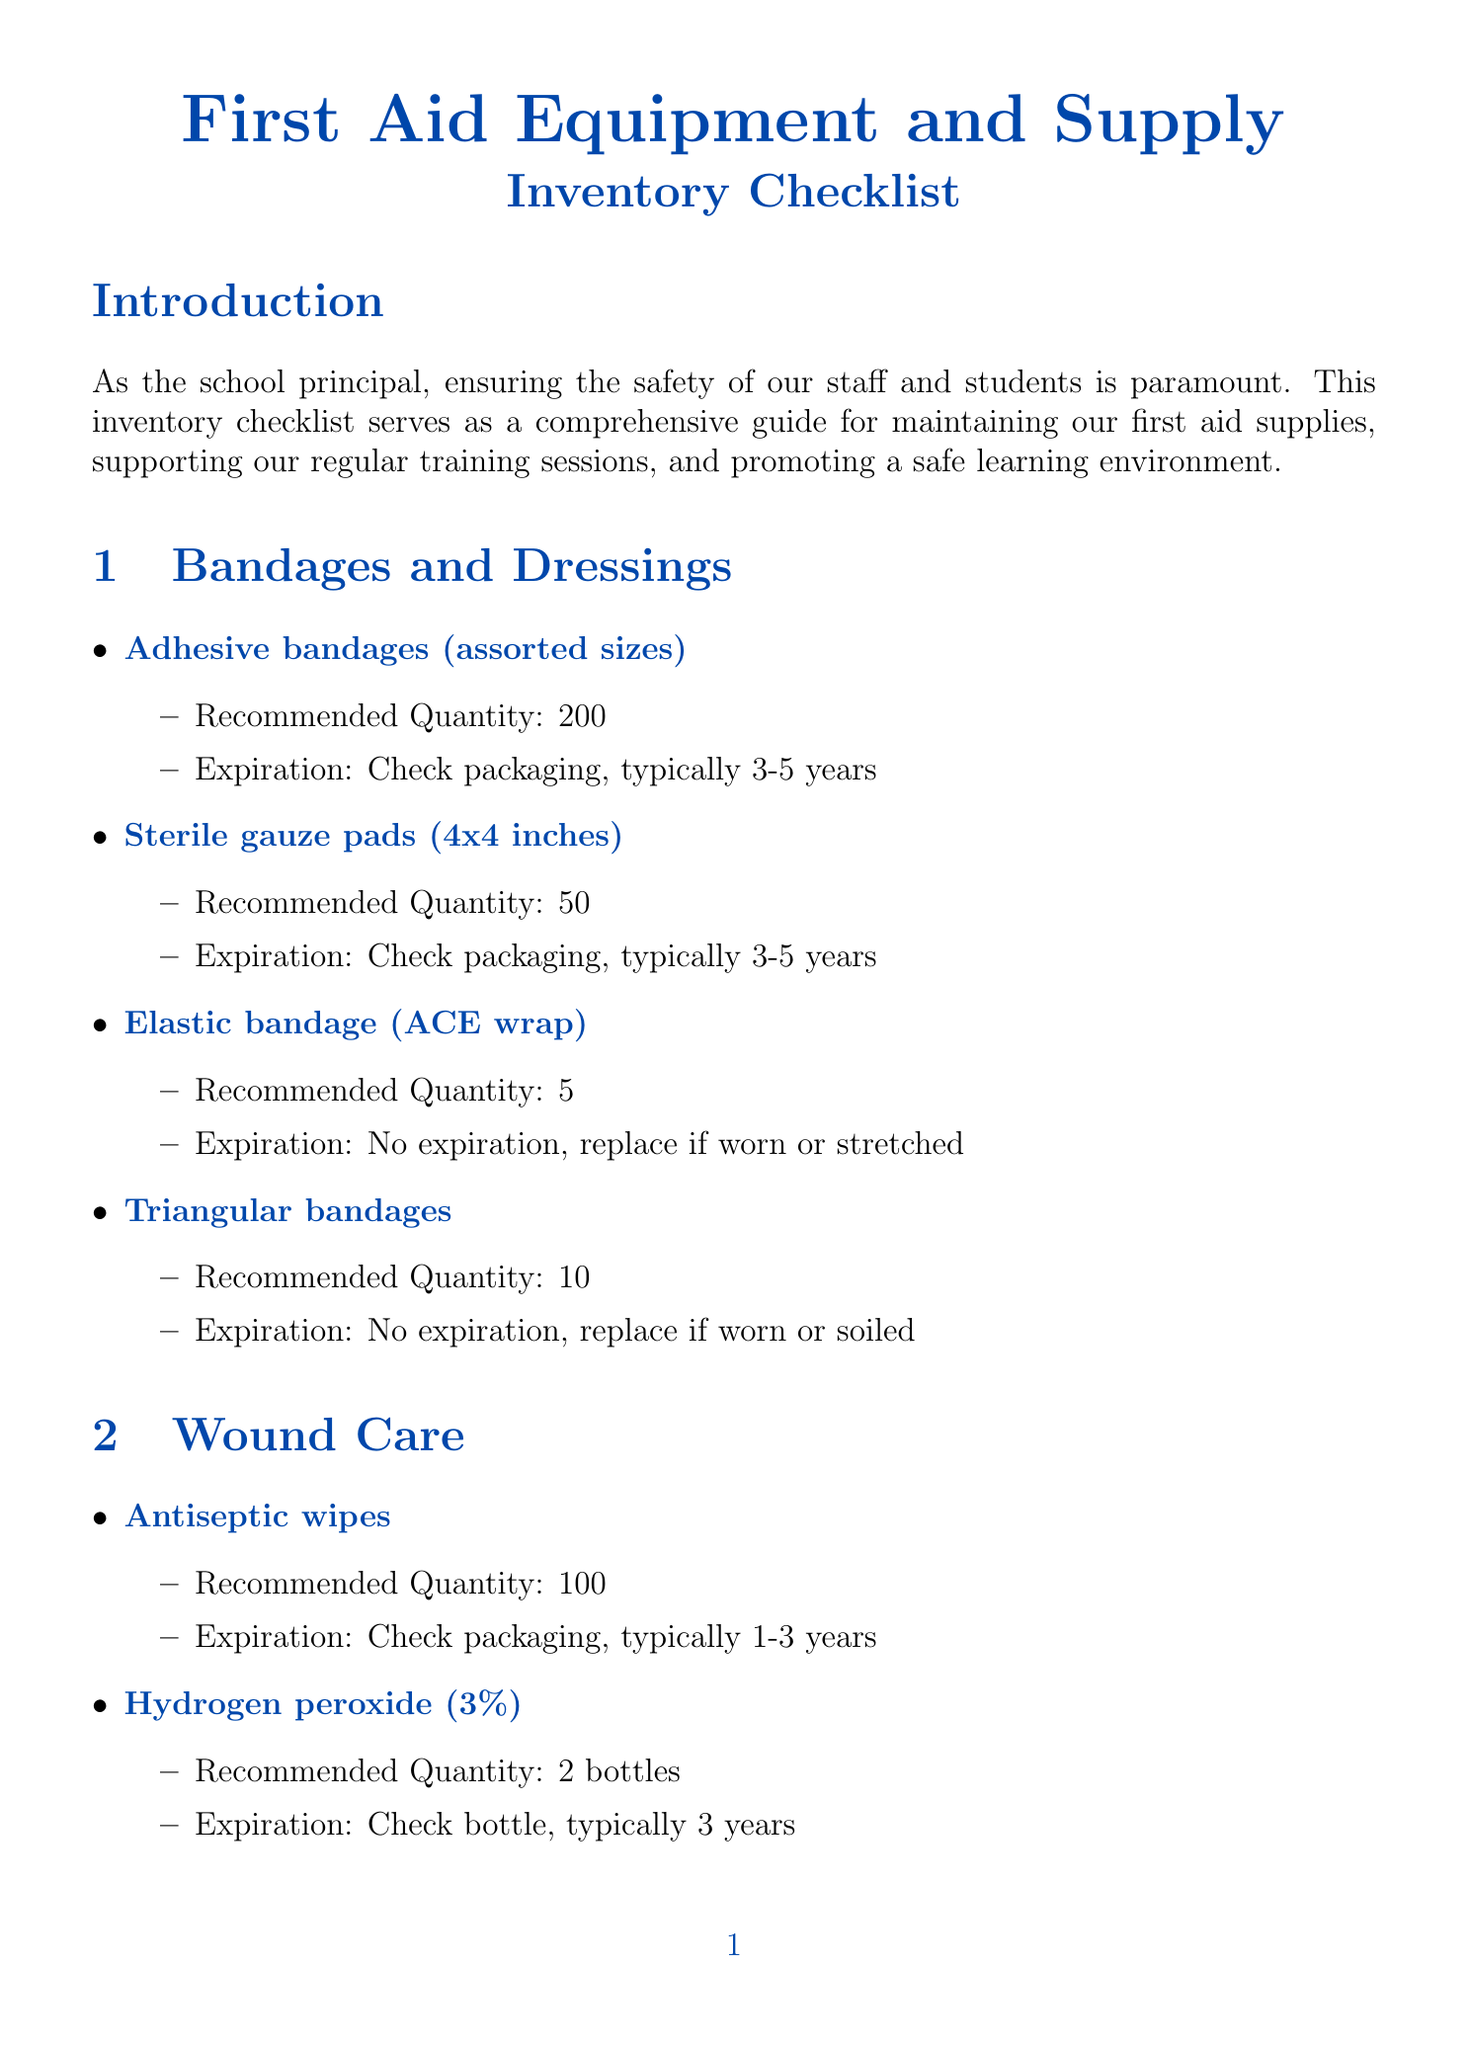what is the recommended quantity of adhesive bandages? The recommended quantity of adhesive bandages (assorted sizes) is listed in the document under the Bandages and Dressings section as 200.
Answer: 200 how long should we check the expiration date of antiseptic wipes? The expiration tracking for antiseptic wipes mentions checking the packaging for an expiration date, which is typically 1-3 years.
Answer: 1-3 years how many digital thermometers are recommended? The document states that the recommended quantity for digital thermometers is 2 in the Tools and Equipment section.
Answer: 2 what type of gloves are suggested in the PPE section? The Personal Protective Equipment section specifies that disposable gloves (nitrile) are recommended.
Answer: disposable gloves (nitrile) how often should the emergency contact list be updated? The document states that the emergency contact list should be updated annually or when changes occur.
Answer: annually what is the expiration tracking for an Automated External Defibrillator (AED)? The expiration tracking for an AED includes checking pads and battery expiration dates, typically every 2-5 years.
Answer: 2-5 years how many incident report forms are listed in the documentation section? The documentation section mentions a recommended quantity of 25 incident report forms.
Answer: 25 what is the minimum quantity of burn gel packets recommended? The document specifies a recommended quantity of 20 burn gel packets in the Wound Care section.
Answer: 20 what category does hydrogen peroxide fall under? Hydrogen peroxide is categorized under Wound Care in the document.
Answer: Wound Care 